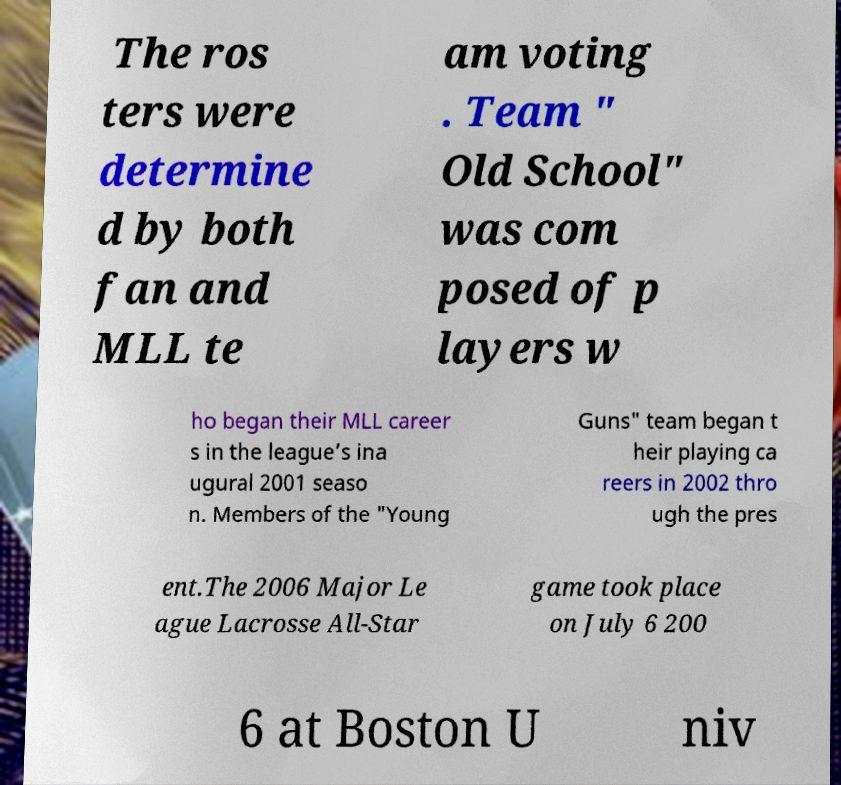What messages or text are displayed in this image? I need them in a readable, typed format. The ros ters were determine d by both fan and MLL te am voting . Team " Old School" was com posed of p layers w ho began their MLL career s in the league’s ina ugural 2001 seaso n. Members of the "Young Guns" team began t heir playing ca reers in 2002 thro ugh the pres ent.The 2006 Major Le ague Lacrosse All-Star game took place on July 6 200 6 at Boston U niv 